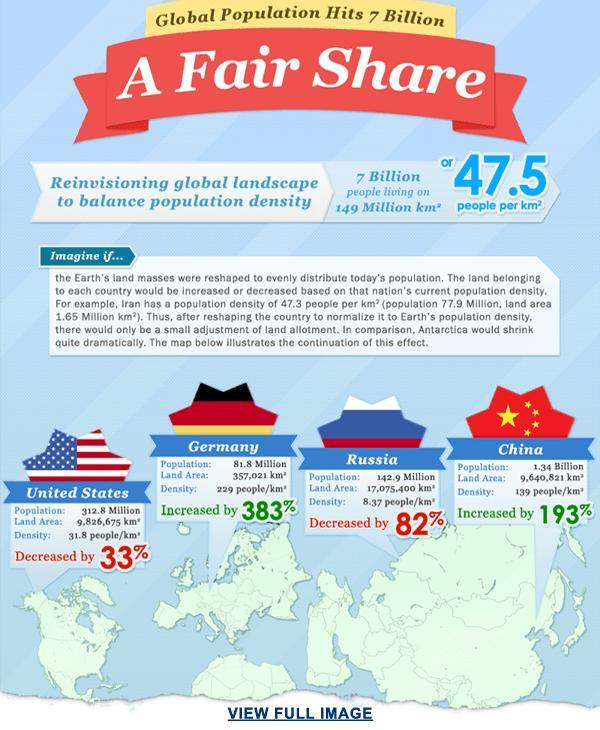Which country has the highest percentage of increase in the population?
Answer the question with a short phrase. Germany Which country has the highest percentage of decrease in the population? Russia 